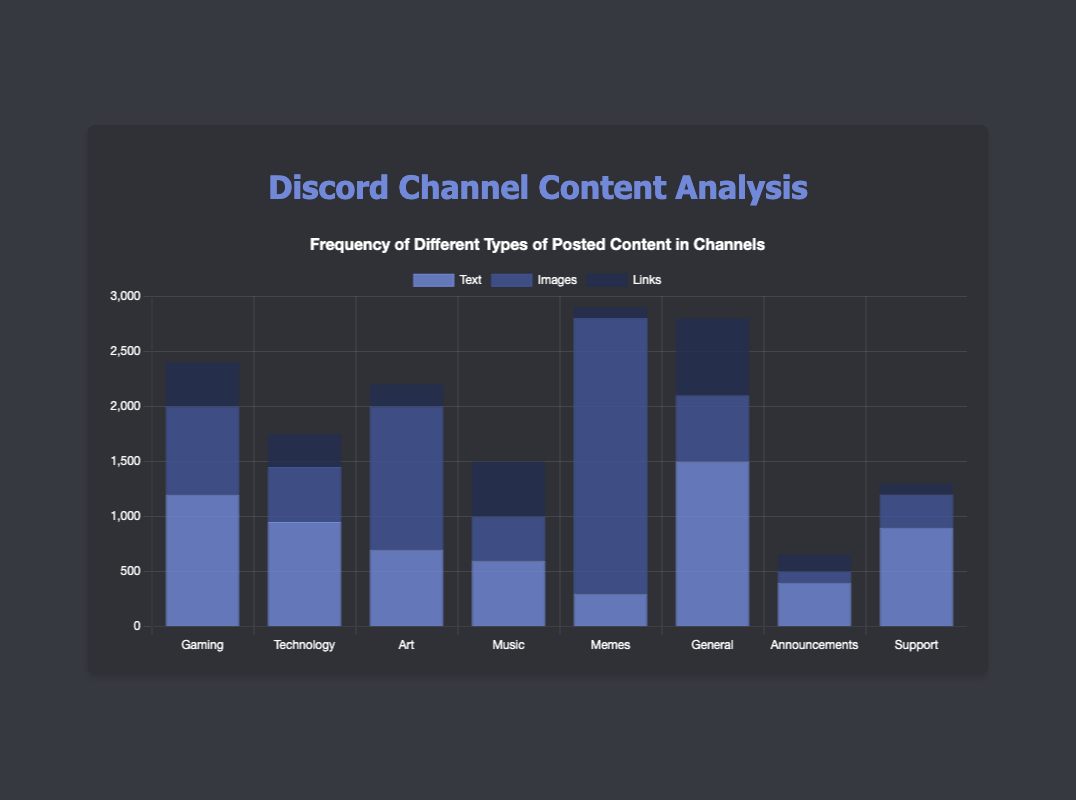Which channel has the most image posts? By comparing the height of the blue bars across all channels, we can see that "Memes" has the tallest blue bar, indicating it has the highest number of image posts.
Answer: Memes What is the total number of text posts in the "Gaming" and "Technology" channels combined? To find the combined total, add the number of text posts in the "Gaming" channel (1200) to the number of text posts in the "Technology" channel (950). Thus, 1200 + 950 = 2150.
Answer: 2150 Which type of content is most frequently posted in the "Music" channel? Looking at the three bars for the "Music" channel, we can see that the text bar is the highest, followed by images, and links. Hence, text posts are the most frequent.
Answer: Text How does the number of link posts in the "General" channel compare to the "Support" channel? The height of the dark blue bars shows that the "General" channel has a higher number of link posts compared to the "Support" channel. Specifically, the "General" channel has 700 link posts, whereas the "Support" channel has 100.
Answer: General > Support What is the difference in the number of image posts between the "Art" and "Gaming" channels? Subtract the number of image posts in the "Gaming" channel (800) from the number of image posts in the "Art" channel (1300). Thus, 1300 - 800 = 500.
Answer: 500 Which channel has the fewest total posts? By summing all types of posts for each channel and comparing the totals, we determine that the "Announcements" channel has the fewest posts (400 + 100 + 150 = 650).
Answer: Announcements Which channel has more image posts: "Technology" or "Support"? By comparing the height of the blue bars for the respective channels, "Technology" has 500 image posts, and "Support" has 300 image posts, so "Technology" has more.
Answer: Technology What is the average number of text posts across all channels? Add up the number of text posts in all channels (1200 + 950 + 700 + 600 + 300 + 1500 + 400 + 900) and divide by the number of channels (8). This equates to a total of 6550 text posts, so 6550 / 8 = 818.75.
Answer: 818.75 What is the total number of image and link posts in the "Memes" channel? Add the number of image posts (2500) and the number of link posts (100) in the "Memes" channel. Thus, 2500 + 100 = 2600.
Answer: 2600 What is the ratio of text posts to image posts in the "General" channel? To find the ratio, divide the number of text posts (1500) by the number of image posts (600). Therefore, the ratio is 1500:600, which simplifies to 5:2.
Answer: 5:2 